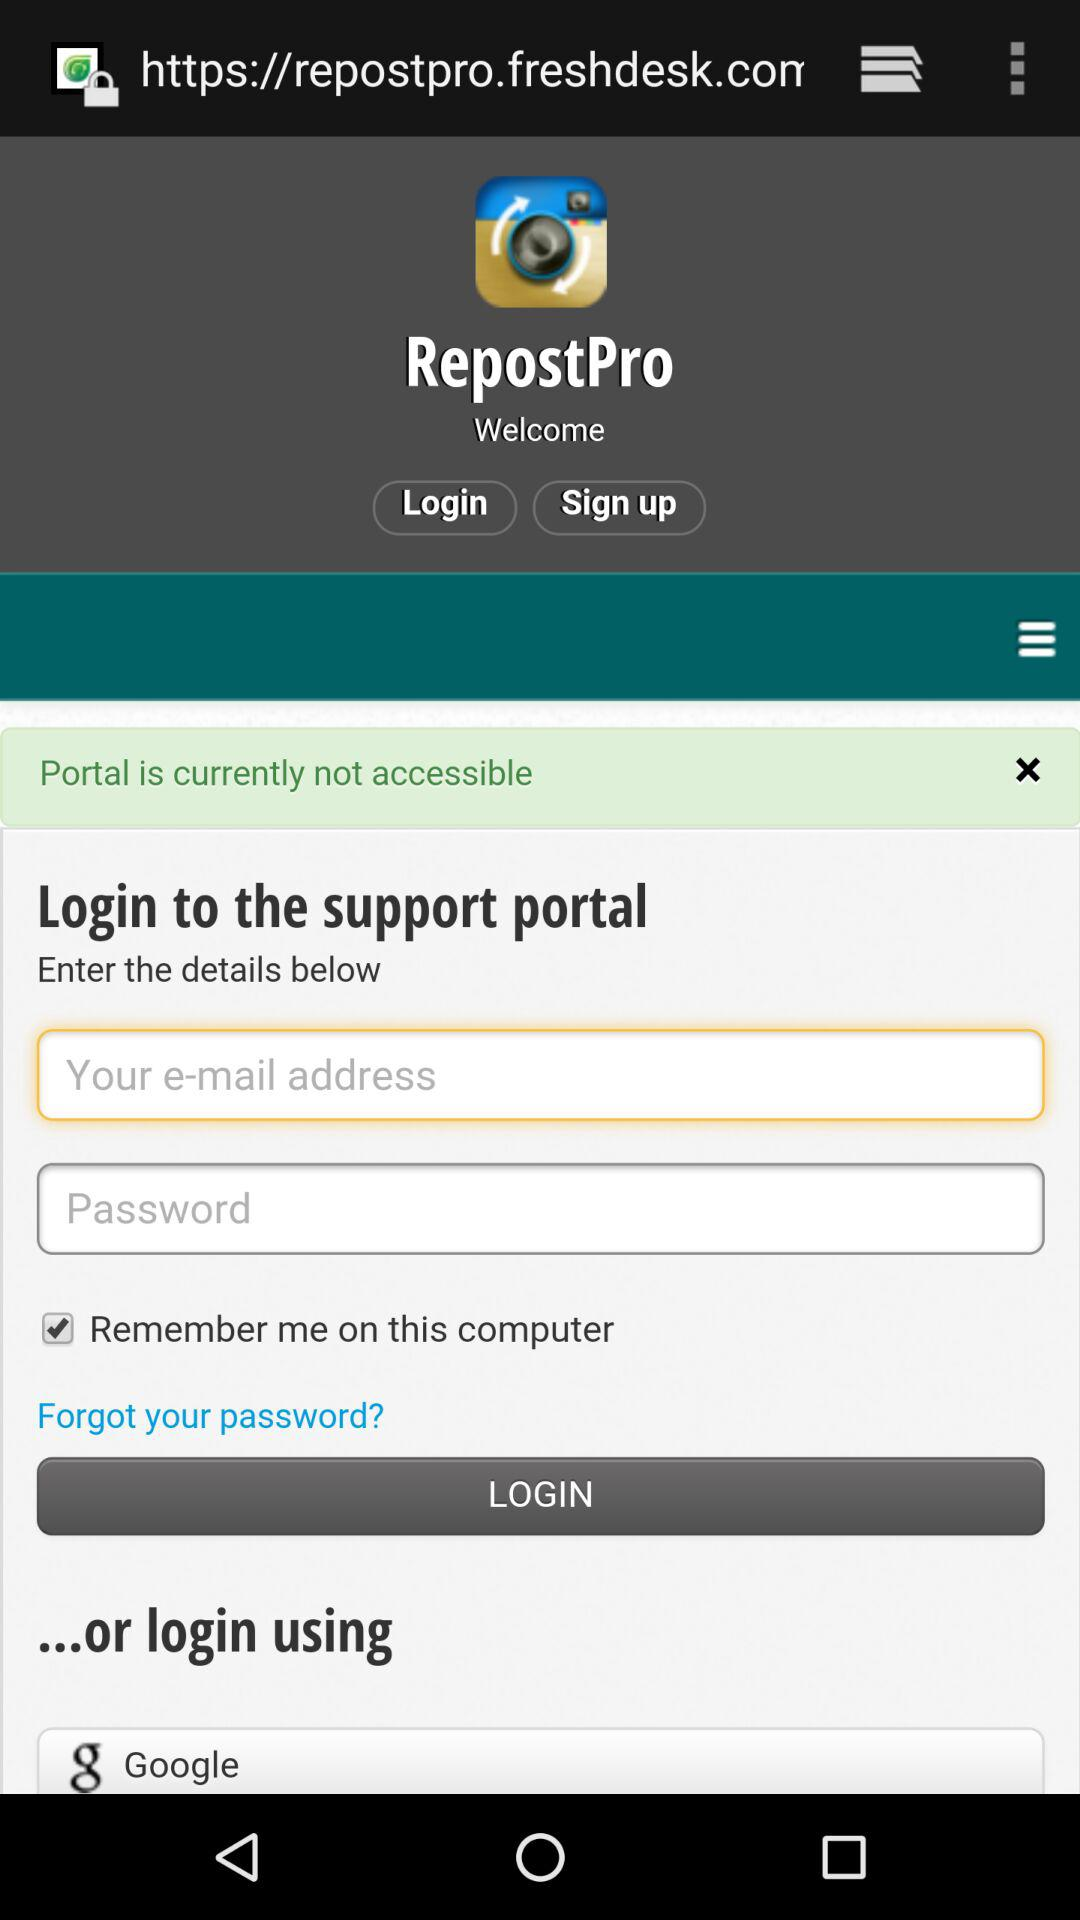What is the name of the application? The name of the application is "RepostPro". 